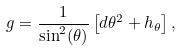<formula> <loc_0><loc_0><loc_500><loc_500>g = \frac { 1 } { \sin ^ { 2 } ( \theta ) } \left [ d \theta ^ { 2 } + h _ { \theta } \right ] ,</formula> 